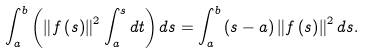<formula> <loc_0><loc_0><loc_500><loc_500>\int _ { a } ^ { b } \left ( \left \| f \left ( s \right ) \right \| ^ { 2 } \int _ { a } ^ { s } d t \right ) d s = \int _ { a } ^ { b } \left ( s - a \right ) \left \| f \left ( s \right ) \right \| ^ { 2 } d s .</formula> 